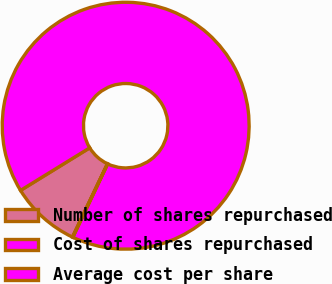<chart> <loc_0><loc_0><loc_500><loc_500><pie_chart><fcel>Number of shares repurchased<fcel>Cost of shares repurchased<fcel>Average cost per share<nl><fcel>9.13%<fcel>90.83%<fcel>0.05%<nl></chart> 